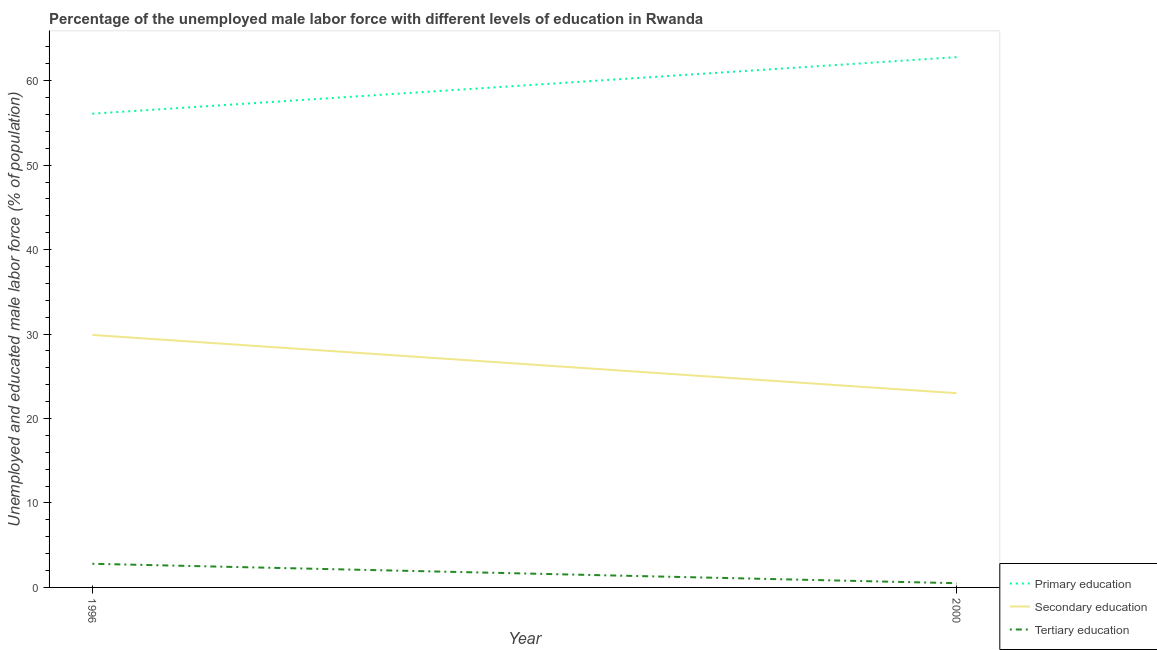Does the line corresponding to percentage of male labor force who received tertiary education intersect with the line corresponding to percentage of male labor force who received primary education?
Your answer should be very brief. No. Is the number of lines equal to the number of legend labels?
Keep it short and to the point. Yes. What is the percentage of male labor force who received secondary education in 1996?
Your answer should be compact. 29.9. Across all years, what is the maximum percentage of male labor force who received tertiary education?
Provide a succinct answer. 2.8. Across all years, what is the minimum percentage of male labor force who received primary education?
Offer a terse response. 56.1. In which year was the percentage of male labor force who received secondary education maximum?
Ensure brevity in your answer.  1996. In which year was the percentage of male labor force who received primary education minimum?
Make the answer very short. 1996. What is the total percentage of male labor force who received secondary education in the graph?
Keep it short and to the point. 52.9. What is the difference between the percentage of male labor force who received secondary education in 1996 and that in 2000?
Provide a succinct answer. 6.9. What is the difference between the percentage of male labor force who received secondary education in 1996 and the percentage of male labor force who received primary education in 2000?
Give a very brief answer. -32.9. What is the average percentage of male labor force who received primary education per year?
Make the answer very short. 59.45. In the year 1996, what is the difference between the percentage of male labor force who received secondary education and percentage of male labor force who received tertiary education?
Ensure brevity in your answer.  27.1. What is the ratio of the percentage of male labor force who received tertiary education in 1996 to that in 2000?
Provide a succinct answer. 5.6. Is the percentage of male labor force who received tertiary education in 1996 less than that in 2000?
Your answer should be compact. No. Does the percentage of male labor force who received primary education monotonically increase over the years?
Ensure brevity in your answer.  Yes. Is the percentage of male labor force who received secondary education strictly less than the percentage of male labor force who received tertiary education over the years?
Your answer should be compact. No. How many lines are there?
Your answer should be very brief. 3. How many years are there in the graph?
Ensure brevity in your answer.  2. Are the values on the major ticks of Y-axis written in scientific E-notation?
Provide a short and direct response. No. Does the graph contain any zero values?
Ensure brevity in your answer.  No. How many legend labels are there?
Your response must be concise. 3. How are the legend labels stacked?
Your answer should be very brief. Vertical. What is the title of the graph?
Provide a short and direct response. Percentage of the unemployed male labor force with different levels of education in Rwanda. What is the label or title of the X-axis?
Your answer should be compact. Year. What is the label or title of the Y-axis?
Offer a terse response. Unemployed and educated male labor force (% of population). What is the Unemployed and educated male labor force (% of population) of Primary education in 1996?
Offer a terse response. 56.1. What is the Unemployed and educated male labor force (% of population) in Secondary education in 1996?
Make the answer very short. 29.9. What is the Unemployed and educated male labor force (% of population) in Tertiary education in 1996?
Offer a very short reply. 2.8. What is the Unemployed and educated male labor force (% of population) of Primary education in 2000?
Provide a short and direct response. 62.8. What is the Unemployed and educated male labor force (% of population) of Secondary education in 2000?
Make the answer very short. 23. What is the Unemployed and educated male labor force (% of population) in Tertiary education in 2000?
Give a very brief answer. 0.5. Across all years, what is the maximum Unemployed and educated male labor force (% of population) of Primary education?
Make the answer very short. 62.8. Across all years, what is the maximum Unemployed and educated male labor force (% of population) of Secondary education?
Keep it short and to the point. 29.9. Across all years, what is the maximum Unemployed and educated male labor force (% of population) in Tertiary education?
Offer a terse response. 2.8. Across all years, what is the minimum Unemployed and educated male labor force (% of population) of Primary education?
Keep it short and to the point. 56.1. Across all years, what is the minimum Unemployed and educated male labor force (% of population) in Tertiary education?
Keep it short and to the point. 0.5. What is the total Unemployed and educated male labor force (% of population) in Primary education in the graph?
Provide a short and direct response. 118.9. What is the total Unemployed and educated male labor force (% of population) of Secondary education in the graph?
Provide a succinct answer. 52.9. What is the total Unemployed and educated male labor force (% of population) in Tertiary education in the graph?
Your response must be concise. 3.3. What is the difference between the Unemployed and educated male labor force (% of population) in Primary education in 1996 and that in 2000?
Provide a succinct answer. -6.7. What is the difference between the Unemployed and educated male labor force (% of population) of Secondary education in 1996 and that in 2000?
Your answer should be compact. 6.9. What is the difference between the Unemployed and educated male labor force (% of population) of Primary education in 1996 and the Unemployed and educated male labor force (% of population) of Secondary education in 2000?
Offer a very short reply. 33.1. What is the difference between the Unemployed and educated male labor force (% of population) of Primary education in 1996 and the Unemployed and educated male labor force (% of population) of Tertiary education in 2000?
Make the answer very short. 55.6. What is the difference between the Unemployed and educated male labor force (% of population) of Secondary education in 1996 and the Unemployed and educated male labor force (% of population) of Tertiary education in 2000?
Your response must be concise. 29.4. What is the average Unemployed and educated male labor force (% of population) in Primary education per year?
Offer a terse response. 59.45. What is the average Unemployed and educated male labor force (% of population) of Secondary education per year?
Provide a short and direct response. 26.45. What is the average Unemployed and educated male labor force (% of population) in Tertiary education per year?
Your answer should be very brief. 1.65. In the year 1996, what is the difference between the Unemployed and educated male labor force (% of population) in Primary education and Unemployed and educated male labor force (% of population) in Secondary education?
Keep it short and to the point. 26.2. In the year 1996, what is the difference between the Unemployed and educated male labor force (% of population) in Primary education and Unemployed and educated male labor force (% of population) in Tertiary education?
Keep it short and to the point. 53.3. In the year 1996, what is the difference between the Unemployed and educated male labor force (% of population) of Secondary education and Unemployed and educated male labor force (% of population) of Tertiary education?
Provide a short and direct response. 27.1. In the year 2000, what is the difference between the Unemployed and educated male labor force (% of population) of Primary education and Unemployed and educated male labor force (% of population) of Secondary education?
Keep it short and to the point. 39.8. In the year 2000, what is the difference between the Unemployed and educated male labor force (% of population) of Primary education and Unemployed and educated male labor force (% of population) of Tertiary education?
Your response must be concise. 62.3. In the year 2000, what is the difference between the Unemployed and educated male labor force (% of population) in Secondary education and Unemployed and educated male labor force (% of population) in Tertiary education?
Your response must be concise. 22.5. What is the ratio of the Unemployed and educated male labor force (% of population) in Primary education in 1996 to that in 2000?
Offer a very short reply. 0.89. What is the ratio of the Unemployed and educated male labor force (% of population) in Tertiary education in 1996 to that in 2000?
Make the answer very short. 5.6. What is the difference between the highest and the second highest Unemployed and educated male labor force (% of population) of Primary education?
Provide a short and direct response. 6.7. What is the difference between the highest and the second highest Unemployed and educated male labor force (% of population) in Tertiary education?
Your answer should be very brief. 2.3. What is the difference between the highest and the lowest Unemployed and educated male labor force (% of population) of Primary education?
Your answer should be very brief. 6.7. What is the difference between the highest and the lowest Unemployed and educated male labor force (% of population) in Tertiary education?
Your response must be concise. 2.3. 